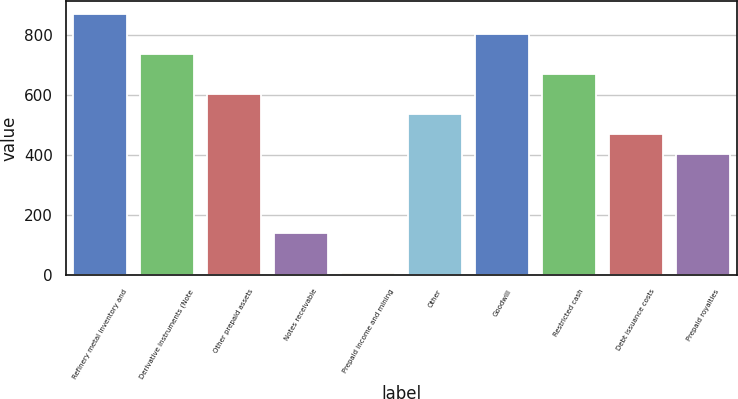Convert chart. <chart><loc_0><loc_0><loc_500><loc_500><bar_chart><fcel>Refinery metal inventory and<fcel>Derivative instruments (Note<fcel>Other prepaid assets<fcel>Notes receivable<fcel>Prepaid income and mining<fcel>Other<fcel>Goodwill<fcel>Restricted cash<fcel>Debt issuance costs<fcel>Prepaid royalties<nl><fcel>870.5<fcel>737.5<fcel>604.5<fcel>139<fcel>6<fcel>538<fcel>804<fcel>671<fcel>471.5<fcel>405<nl></chart> 